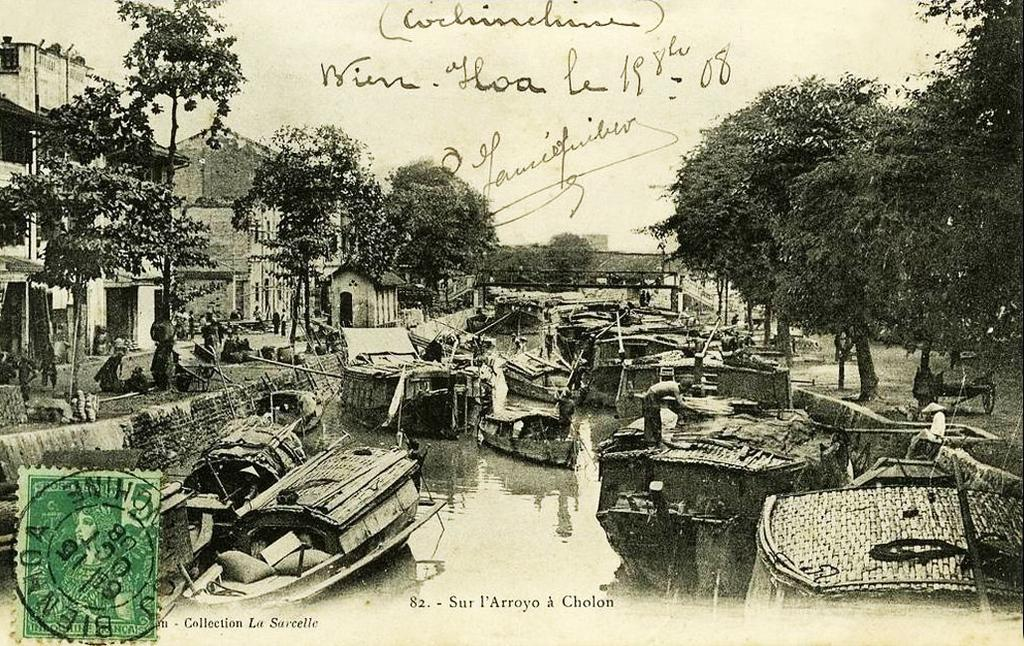What is the main feature in the center of the image? There is a canal in the center of the image. What is present in the canal? There are boats in the canal. What can be seen in the background of the image? There are trees, buildings, and a bridge in the background of the image. What is visible in the sky in the image? The sky is visible in the background of the image. What type of polish is being applied to the brake in the image? There is no mention of polish or a brake in the image; it features a canal with boats and a background with trees, buildings, and a bridge. 